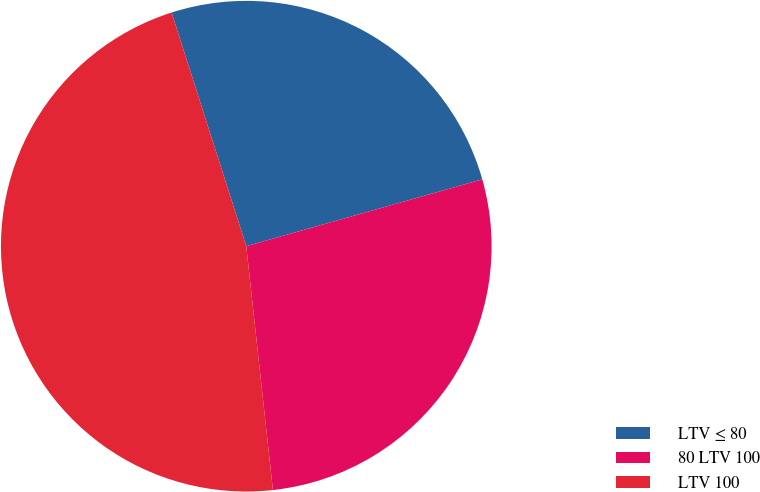Convert chart. <chart><loc_0><loc_0><loc_500><loc_500><pie_chart><fcel>LTV ≤ 80<fcel>80 LTV 100<fcel>LTV 100<nl><fcel>25.53%<fcel>27.66%<fcel>46.81%<nl></chart> 